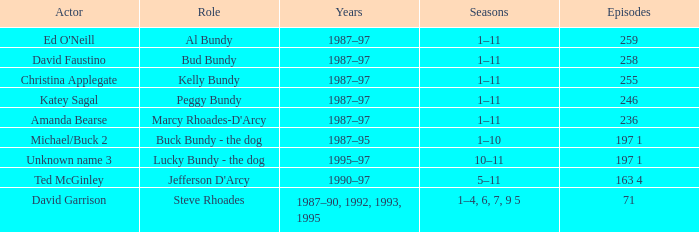What is the total number of episodes featuring actor david faustino? 258.0. 